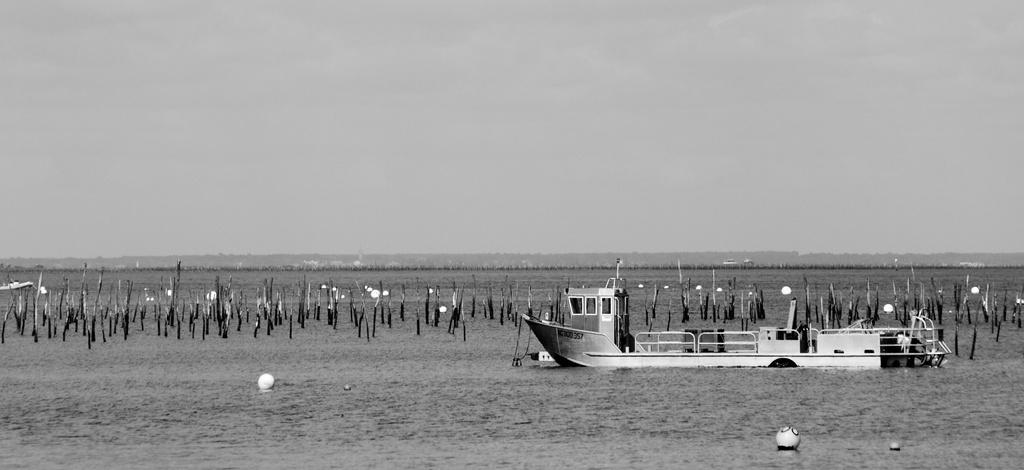What type of vehicles are present in the image? There are boats in the image. What objects are made of wood in the image? There are wooden sticks in the image. What natural element is visible in the image? There is water in the image. What type of landscape can be seen in the background of the image? There are mountains in the background of the image. What is visible in the sky in the image? The sky is visible in the background of the image. Reasoning: Let's think step by step by step in order to produce the conversation. We start by identifying the main subjects and objects in the image, such as the boats, wooden sticks, water, mountains, and sky. Then, we formulate questions that focus on the characteristics and locations of these subjects and objects, ensuring that each question can be answered definitively with the information given. We avoid yes/no questions and ensure that the language is simple and clear. Absurd Question/Answer: Where is the scarecrow located in the image? There is no scarecrow present in the image. What is the mass of the boats in the image? The mass of the boats cannot be determined from the image alone, as it does not provide information about their size or weight. Are the boats in the image sleeping? Boats do not sleep, as they are inanimate objects. The image only shows the boats in their stationary state. 